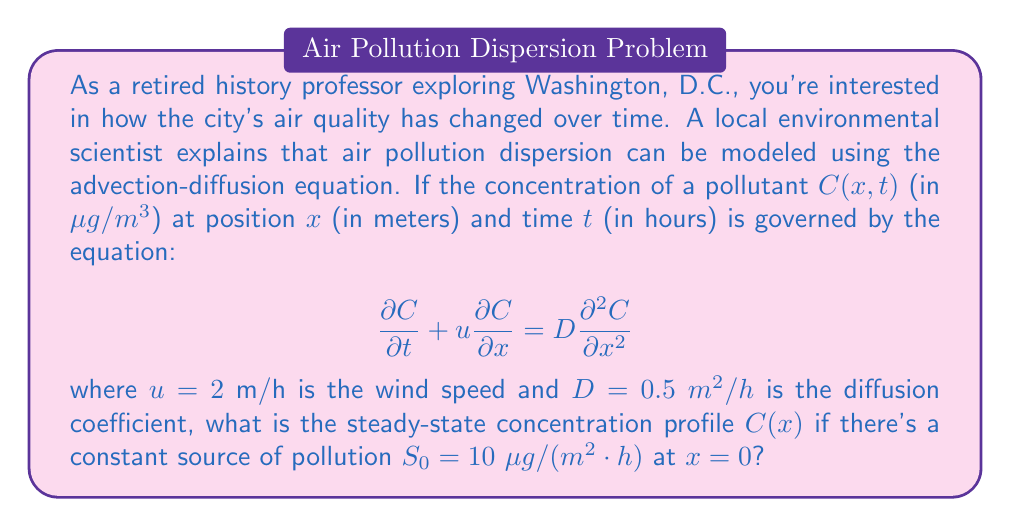Help me with this question. To solve this problem, we'll follow these steps:

1) For a steady-state solution, the concentration doesn't change with time, so $\frac{\partial C}{\partial t} = 0$. The equation becomes:

   $$u\frac{dC}{dx} = D\frac{d^2C}{dx^2}$$

2) This is a second-order ordinary differential equation. We can solve it by integrating twice:

   $$\frac{dC}{dx} = \frac{u}{D}C + A$$

   $$C = \frac{D}{u}(\frac{u}{D}C + A) + B = C + \frac{DA}{u} + B$$

   Where $A$ and $B$ are constants of integration.

3) The second equation implies $\frac{DA}{u} + B = 0$, or $B = -\frac{DA}{u}$.

4) The general solution is thus:

   $$C(x) = Ae^{\frac{u}{D}x} + B$$

5) We need boundary conditions to determine $A$ and $B$. At $x \to \infty$, we expect $C \to 0$, which means $B = 0$.

6) For the other boundary condition, we use the fact that there's a constant source at $x = 0$. This means:

   $$-D\frac{dC}{dx}|_{x=0} = S_0$$

7) Differentiating our solution and applying this condition:

   $$-D\frac{dC}{dx}|_{x=0} = -DAe^{\frac{u}{D}x}\frac{u}{D}|_{x=0} = -Au = S_0$$

8) Solving for $A$:

   $$A = -\frac{S_0}{u}$$

9) Therefore, the final solution is:

   $$C(x) = -\frac{S_0}{u}e^{\frac{u}{D}x} = -\frac{10}{2}e^{\frac{2}{0.5}x} = -5e^{4x}$$

This represents the steady-state concentration profile of the pollutant.
Answer: $C(x) = -5e^{4x}$ $\mu g/m^3$ 